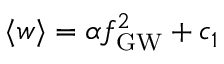Convert formula to latex. <formula><loc_0><loc_0><loc_500><loc_500>{ \langle w \rangle } = \alpha { f _ { G W } } ^ { 2 } + c _ { 1 }</formula> 